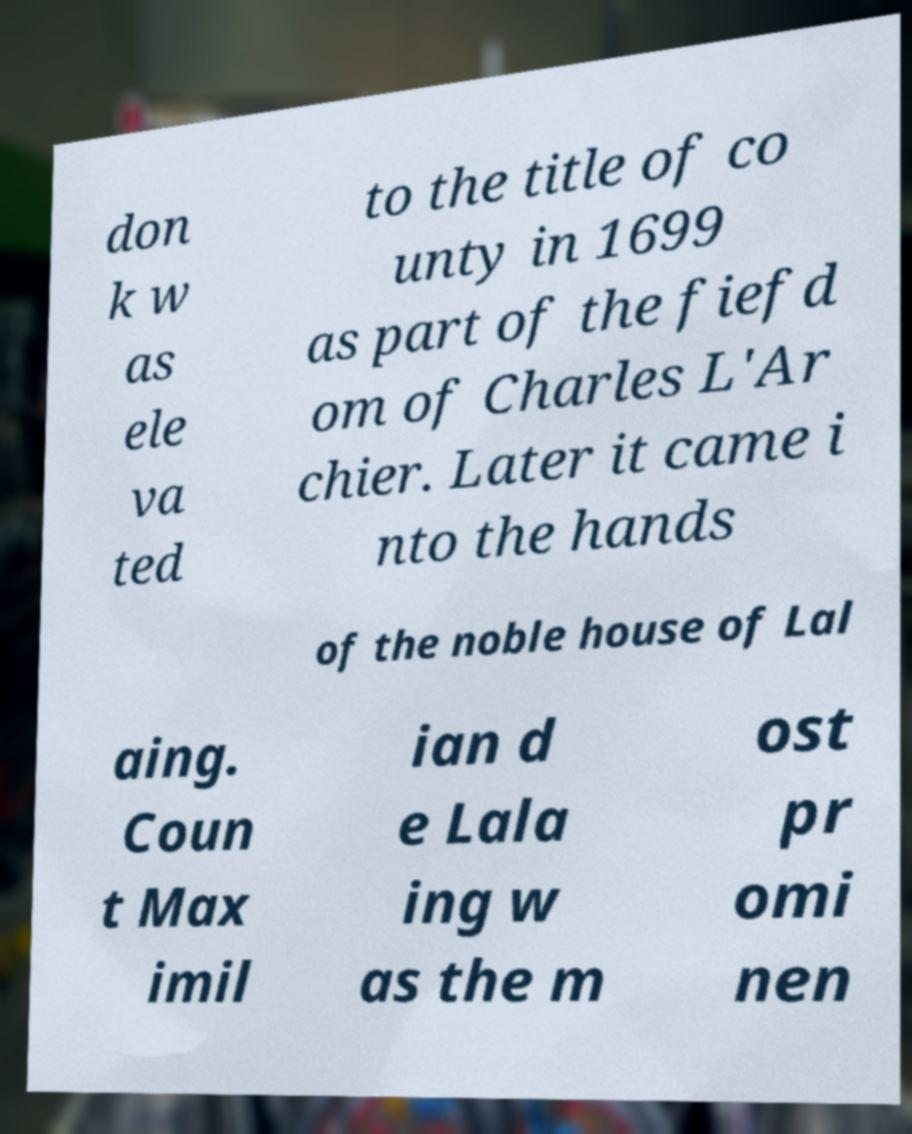I need the written content from this picture converted into text. Can you do that? don k w as ele va ted to the title of co unty in 1699 as part of the fiefd om of Charles L'Ar chier. Later it came i nto the hands of the noble house of Lal aing. Coun t Max imil ian d e Lala ing w as the m ost pr omi nen 